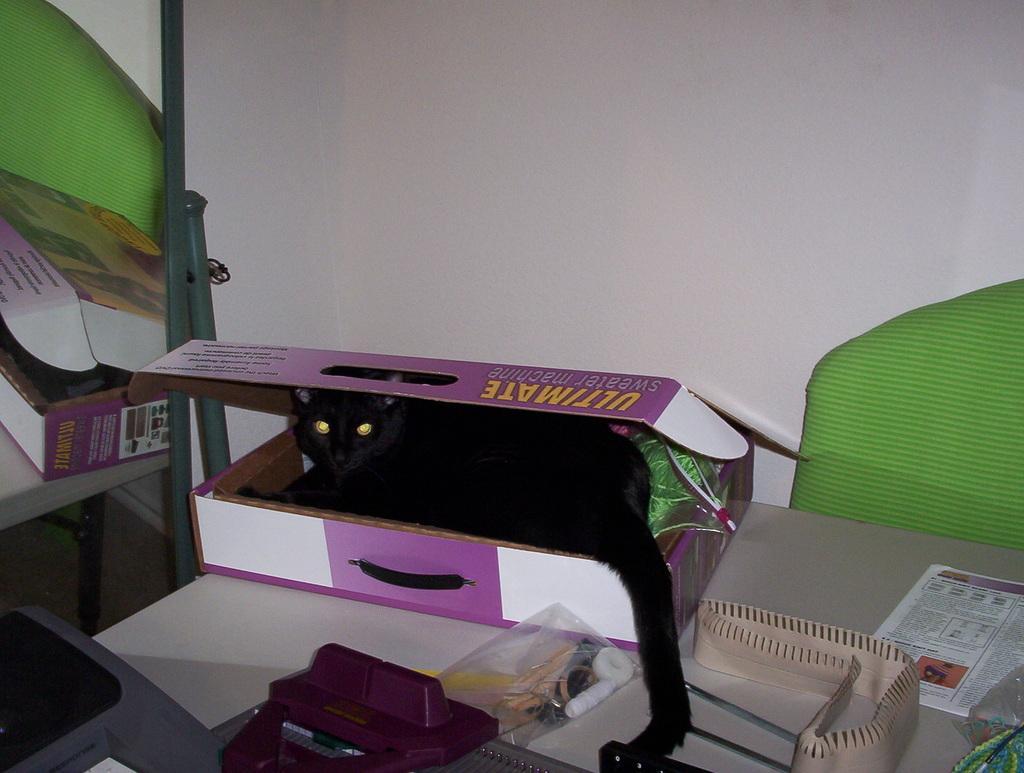Describe this image in one or two sentences. In this image I can see a black color cat in the cardboard box. I can see few objects on the white color table. Back I can see the white wall. 